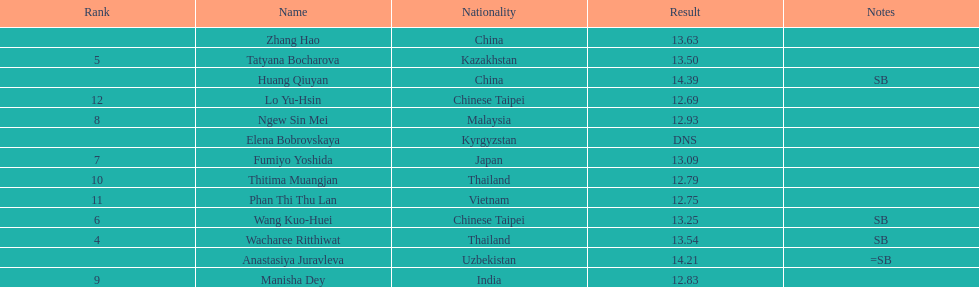What is the difference between huang qiuyan's result and fumiyo yoshida's result? 1.3. 